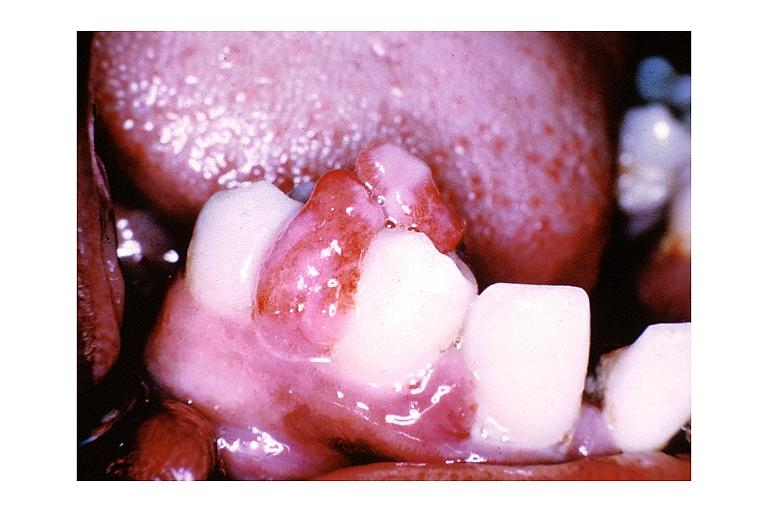does this image show pyogenic granuloma?
Answer the question using a single word or phrase. Yes 